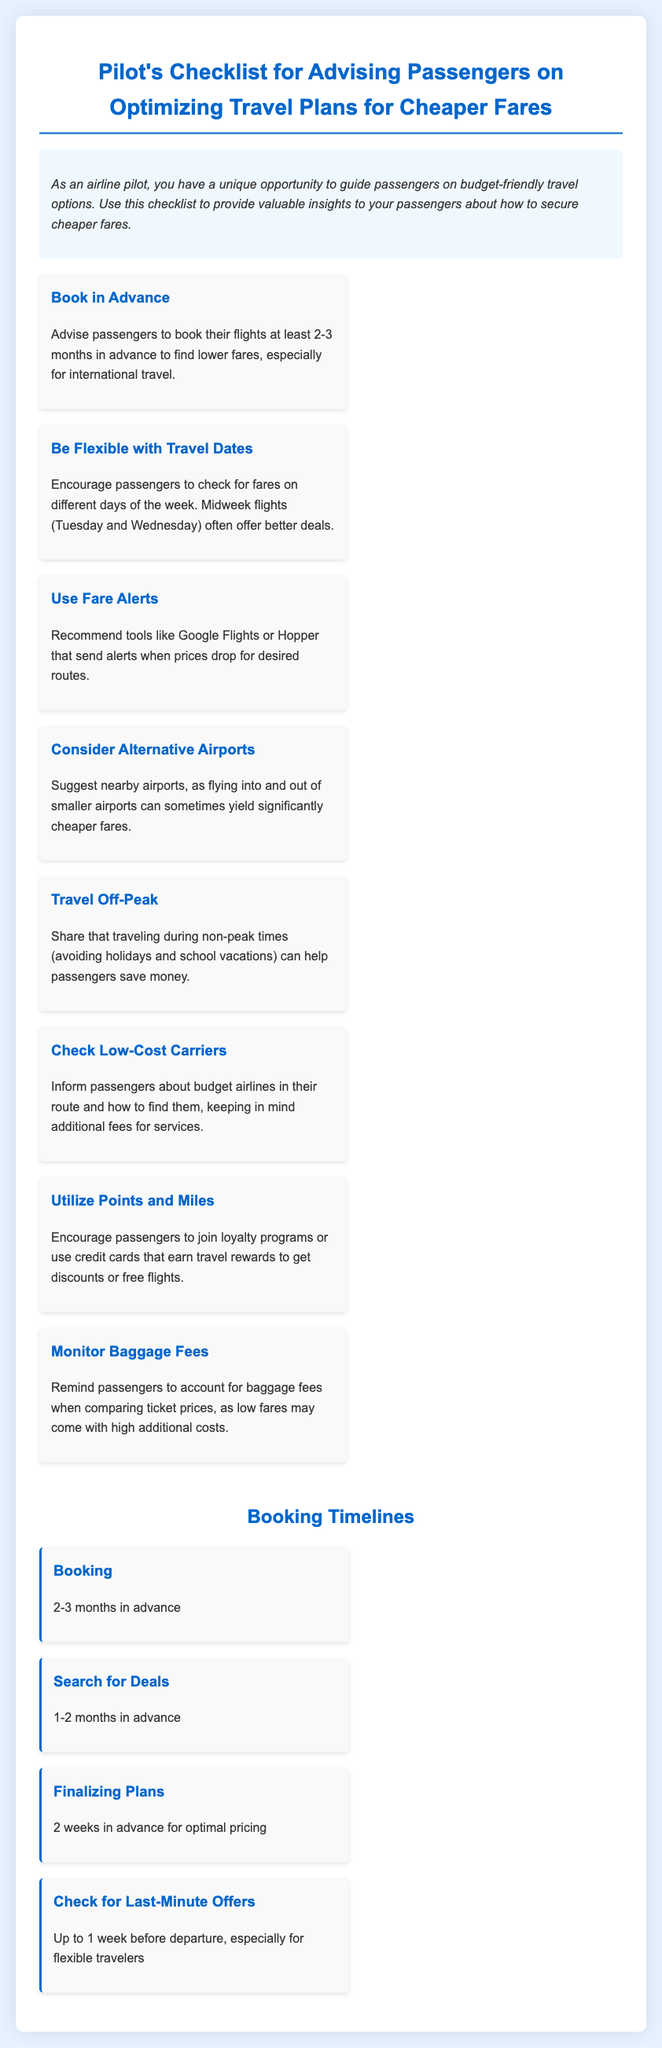What is the ideal time to book a flight for lower fares? The document states that booking flights should be done at least 2-3 months in advance for lower fares.
Answer: 2-3 months in advance Which days of the week offer better flight deals? The document indicates that midweek flights, specifically Tuesday and Wednesday, often have better fares.
Answer: Tuesday and Wednesday What tool is recommended for fare alerts? The document recommends tools like Google Flights or Hopper for tracking price drops.
Answer: Google Flights or Hopper What should passengers consider when comparing ticket prices? The document advises passengers to monitor baggage fees when comparing ticket prices, as they can significantly affect the total cost.
Answer: Baggage fees When should passengers search for deals? According to the document, passengers should search for deals 1-2 months in advance.
Answer: 1-2 months in advance What is suggested for passengers who travel during non-peak times? The document suggests that traveling during non-peak times can help passengers save money.
Answer: Save money How long before departure should passengers check for last-minute offers? The document states that passengers should check for last-minute offers up to 1 week before departure.
Answer: Up to 1 week before departure What is the benefit of joining loyalty programs? The document indicates that joining loyalty programs can earn travel rewards that offer discounts or free flights.
Answer: Discounts or free flights 